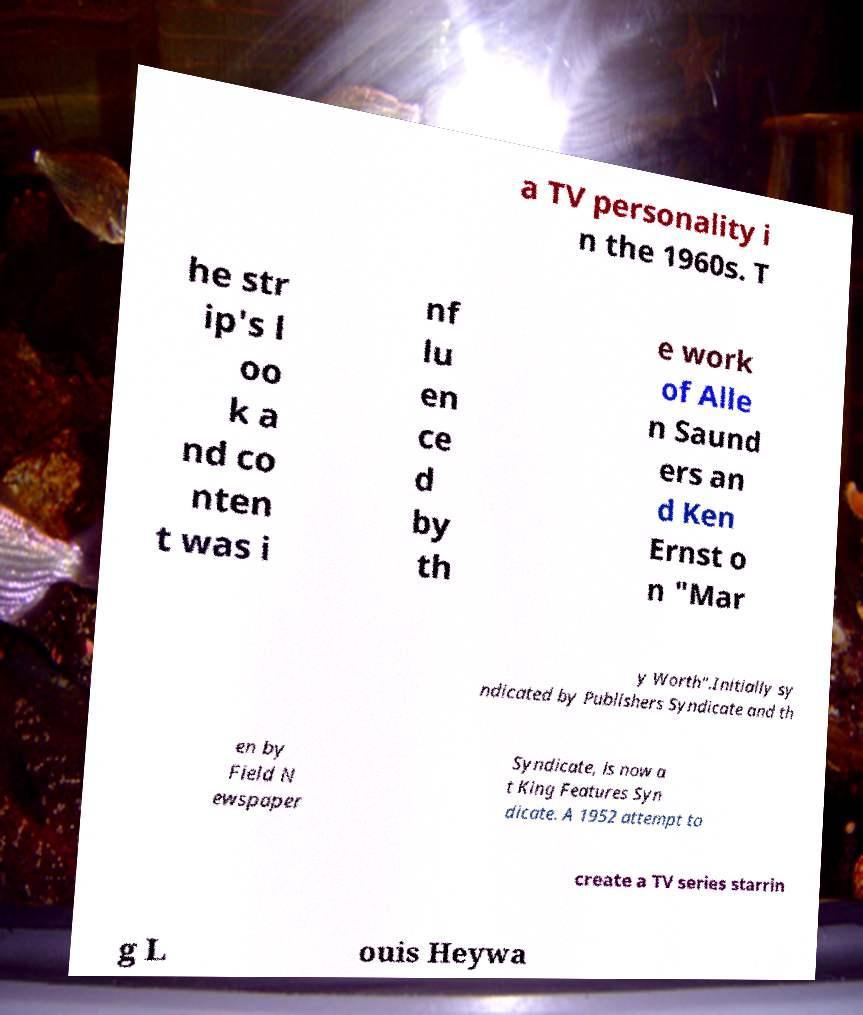Please read and relay the text visible in this image. What does it say? a TV personality i n the 1960s. T he str ip's l oo k a nd co nten t was i nf lu en ce d by th e work of Alle n Saund ers an d Ken Ernst o n "Mar y Worth".Initially sy ndicated by Publishers Syndicate and th en by Field N ewspaper Syndicate, is now a t King Features Syn dicate. A 1952 attempt to create a TV series starrin g L ouis Heywa 